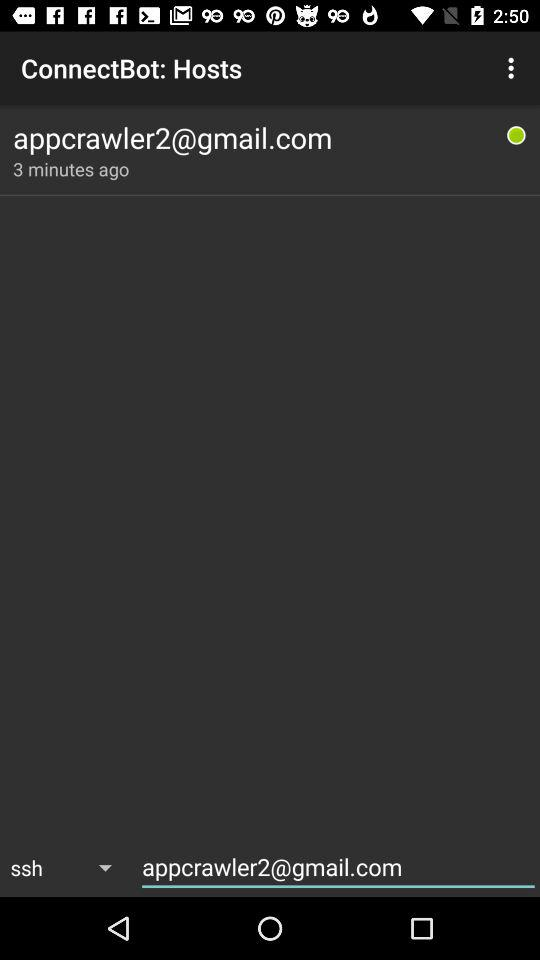What is the email address? The email address is appcrawler2@gmail.com. 